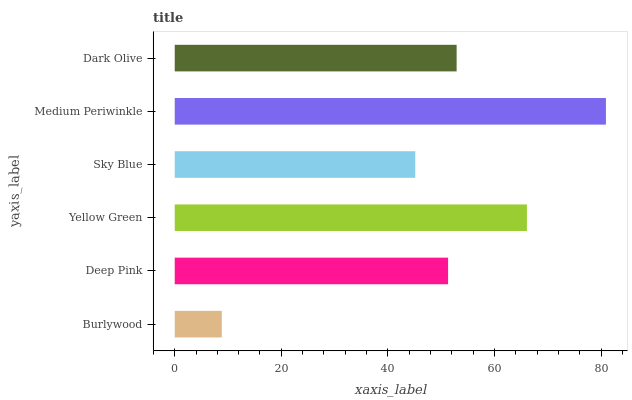Is Burlywood the minimum?
Answer yes or no. Yes. Is Medium Periwinkle the maximum?
Answer yes or no. Yes. Is Deep Pink the minimum?
Answer yes or no. No. Is Deep Pink the maximum?
Answer yes or no. No. Is Deep Pink greater than Burlywood?
Answer yes or no. Yes. Is Burlywood less than Deep Pink?
Answer yes or no. Yes. Is Burlywood greater than Deep Pink?
Answer yes or no. No. Is Deep Pink less than Burlywood?
Answer yes or no. No. Is Dark Olive the high median?
Answer yes or no. Yes. Is Deep Pink the low median?
Answer yes or no. Yes. Is Burlywood the high median?
Answer yes or no. No. Is Yellow Green the low median?
Answer yes or no. No. 